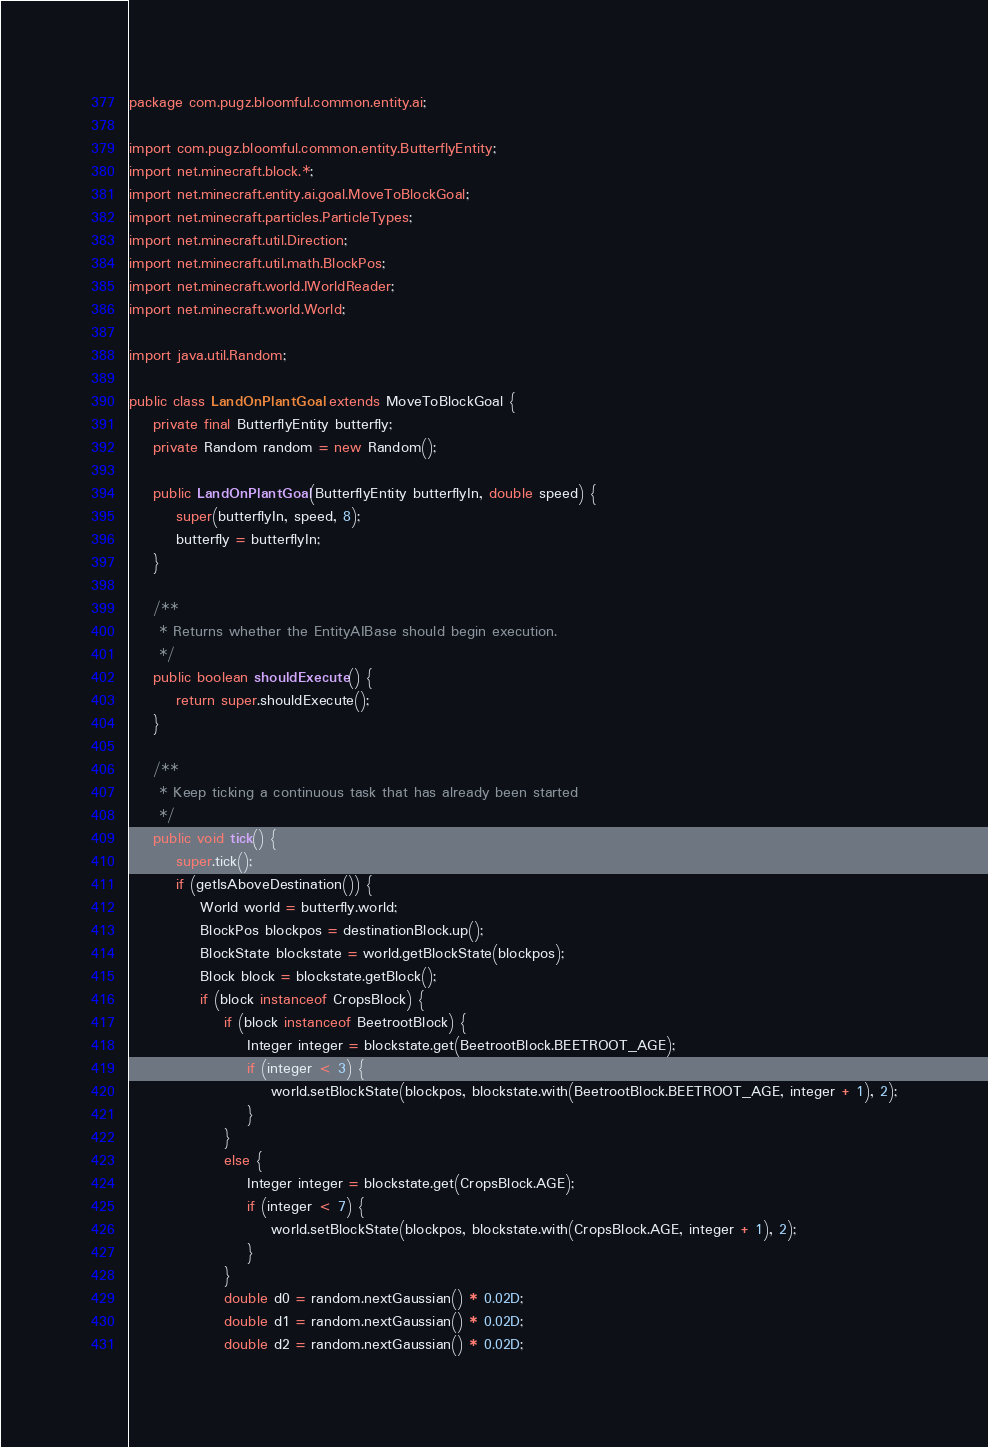<code> <loc_0><loc_0><loc_500><loc_500><_Java_>package com.pugz.bloomful.common.entity.ai;

import com.pugz.bloomful.common.entity.ButterflyEntity;
import net.minecraft.block.*;
import net.minecraft.entity.ai.goal.MoveToBlockGoal;
import net.minecraft.particles.ParticleTypes;
import net.minecraft.util.Direction;
import net.minecraft.util.math.BlockPos;
import net.minecraft.world.IWorldReader;
import net.minecraft.world.World;

import java.util.Random;

public class LandOnPlantGoal extends MoveToBlockGoal {
    private final ButterflyEntity butterfly;
    private Random random = new Random();

    public LandOnPlantGoal(ButterflyEntity butterflyIn, double speed) {
        super(butterflyIn, speed, 8);
        butterfly = butterflyIn;
    }

    /**
     * Returns whether the EntityAIBase should begin execution.
     */
    public boolean shouldExecute() {
        return super.shouldExecute();
    }

    /**
     * Keep ticking a continuous task that has already been started
     */
    public void tick() {
        super.tick();
        if (getIsAboveDestination()) {
            World world = butterfly.world;
            BlockPos blockpos = destinationBlock.up();
            BlockState blockstate = world.getBlockState(blockpos);
            Block block = blockstate.getBlock();
            if (block instanceof CropsBlock) {
                if (block instanceof BeetrootBlock) {
                    Integer integer = blockstate.get(BeetrootBlock.BEETROOT_AGE);
                    if (integer < 3) {
                        world.setBlockState(blockpos, blockstate.with(BeetrootBlock.BEETROOT_AGE, integer + 1), 2);
                    }
                }
                else {
                    Integer integer = blockstate.get(CropsBlock.AGE);
                    if (integer < 7) {
                        world.setBlockState(blockpos, blockstate.with(CropsBlock.AGE, integer + 1), 2);
                    }
                }
                double d0 = random.nextGaussian() * 0.02D;
                double d1 = random.nextGaussian() * 0.02D;
                double d2 = random.nextGaussian() * 0.02D;</code> 